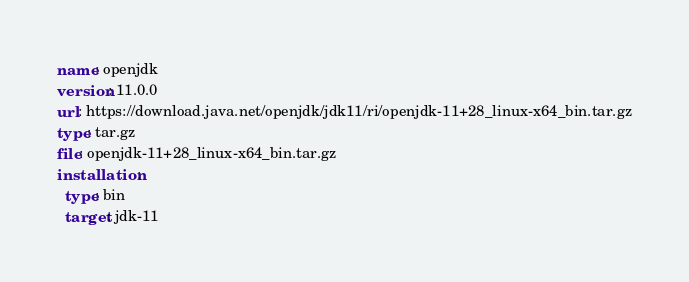Convert code to text. <code><loc_0><loc_0><loc_500><loc_500><_YAML_>name: openjdk
version: 11.0.0
url: https://download.java.net/openjdk/jdk11/ri/openjdk-11+28_linux-x64_bin.tar.gz
type: tar.gz
file: openjdk-11+28_linux-x64_bin.tar.gz
installation:
  type: bin
  target: jdk-11
</code> 